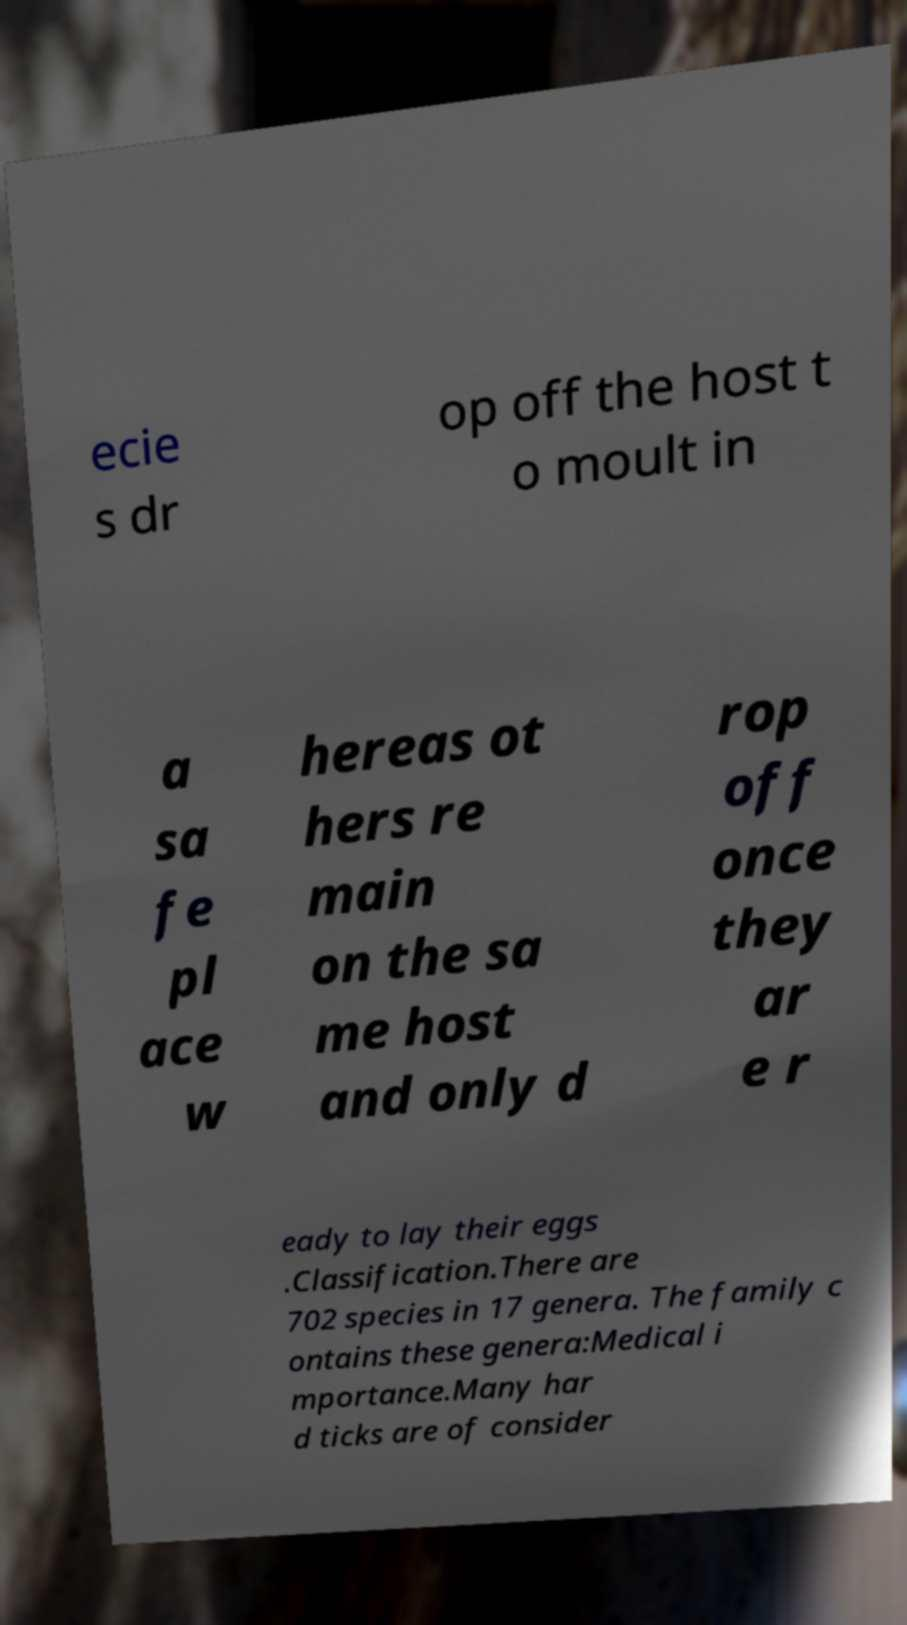What messages or text are displayed in this image? I need them in a readable, typed format. ecie s dr op off the host t o moult in a sa fe pl ace w hereas ot hers re main on the sa me host and only d rop off once they ar e r eady to lay their eggs .Classification.There are 702 species in 17 genera. The family c ontains these genera:Medical i mportance.Many har d ticks are of consider 